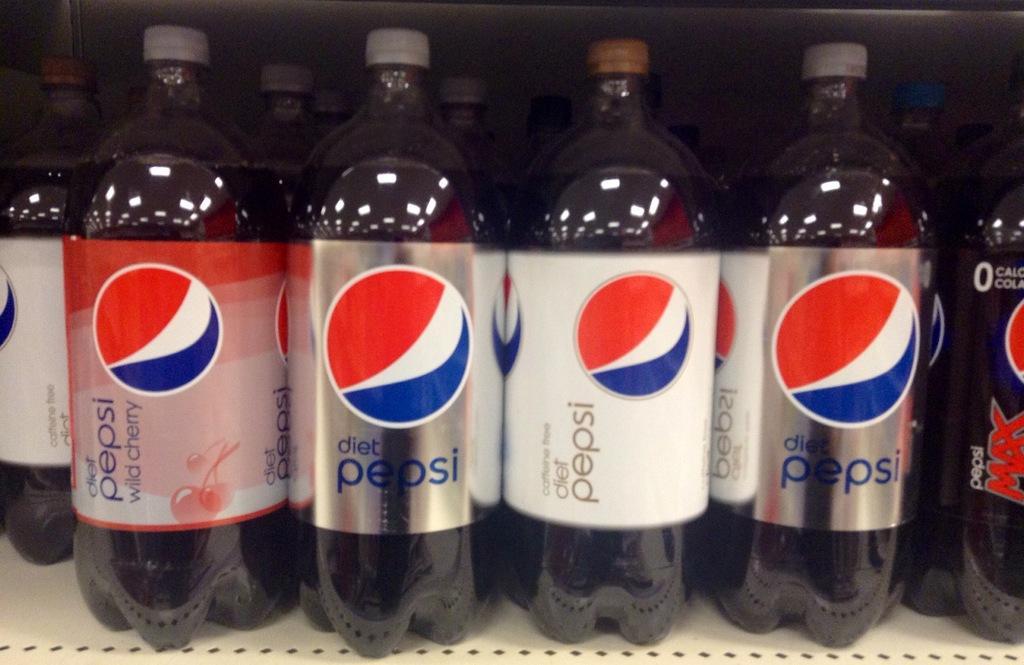How would you summarize this image in a sentence or two? This is a picture in a shelf of a Pepsi bottles. 